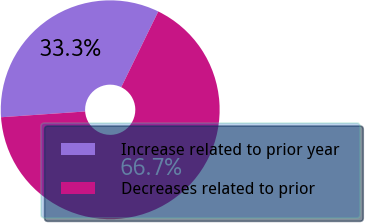Convert chart. <chart><loc_0><loc_0><loc_500><loc_500><pie_chart><fcel>Increase related to prior year<fcel>Decreases related to prior<nl><fcel>33.33%<fcel>66.67%<nl></chart> 